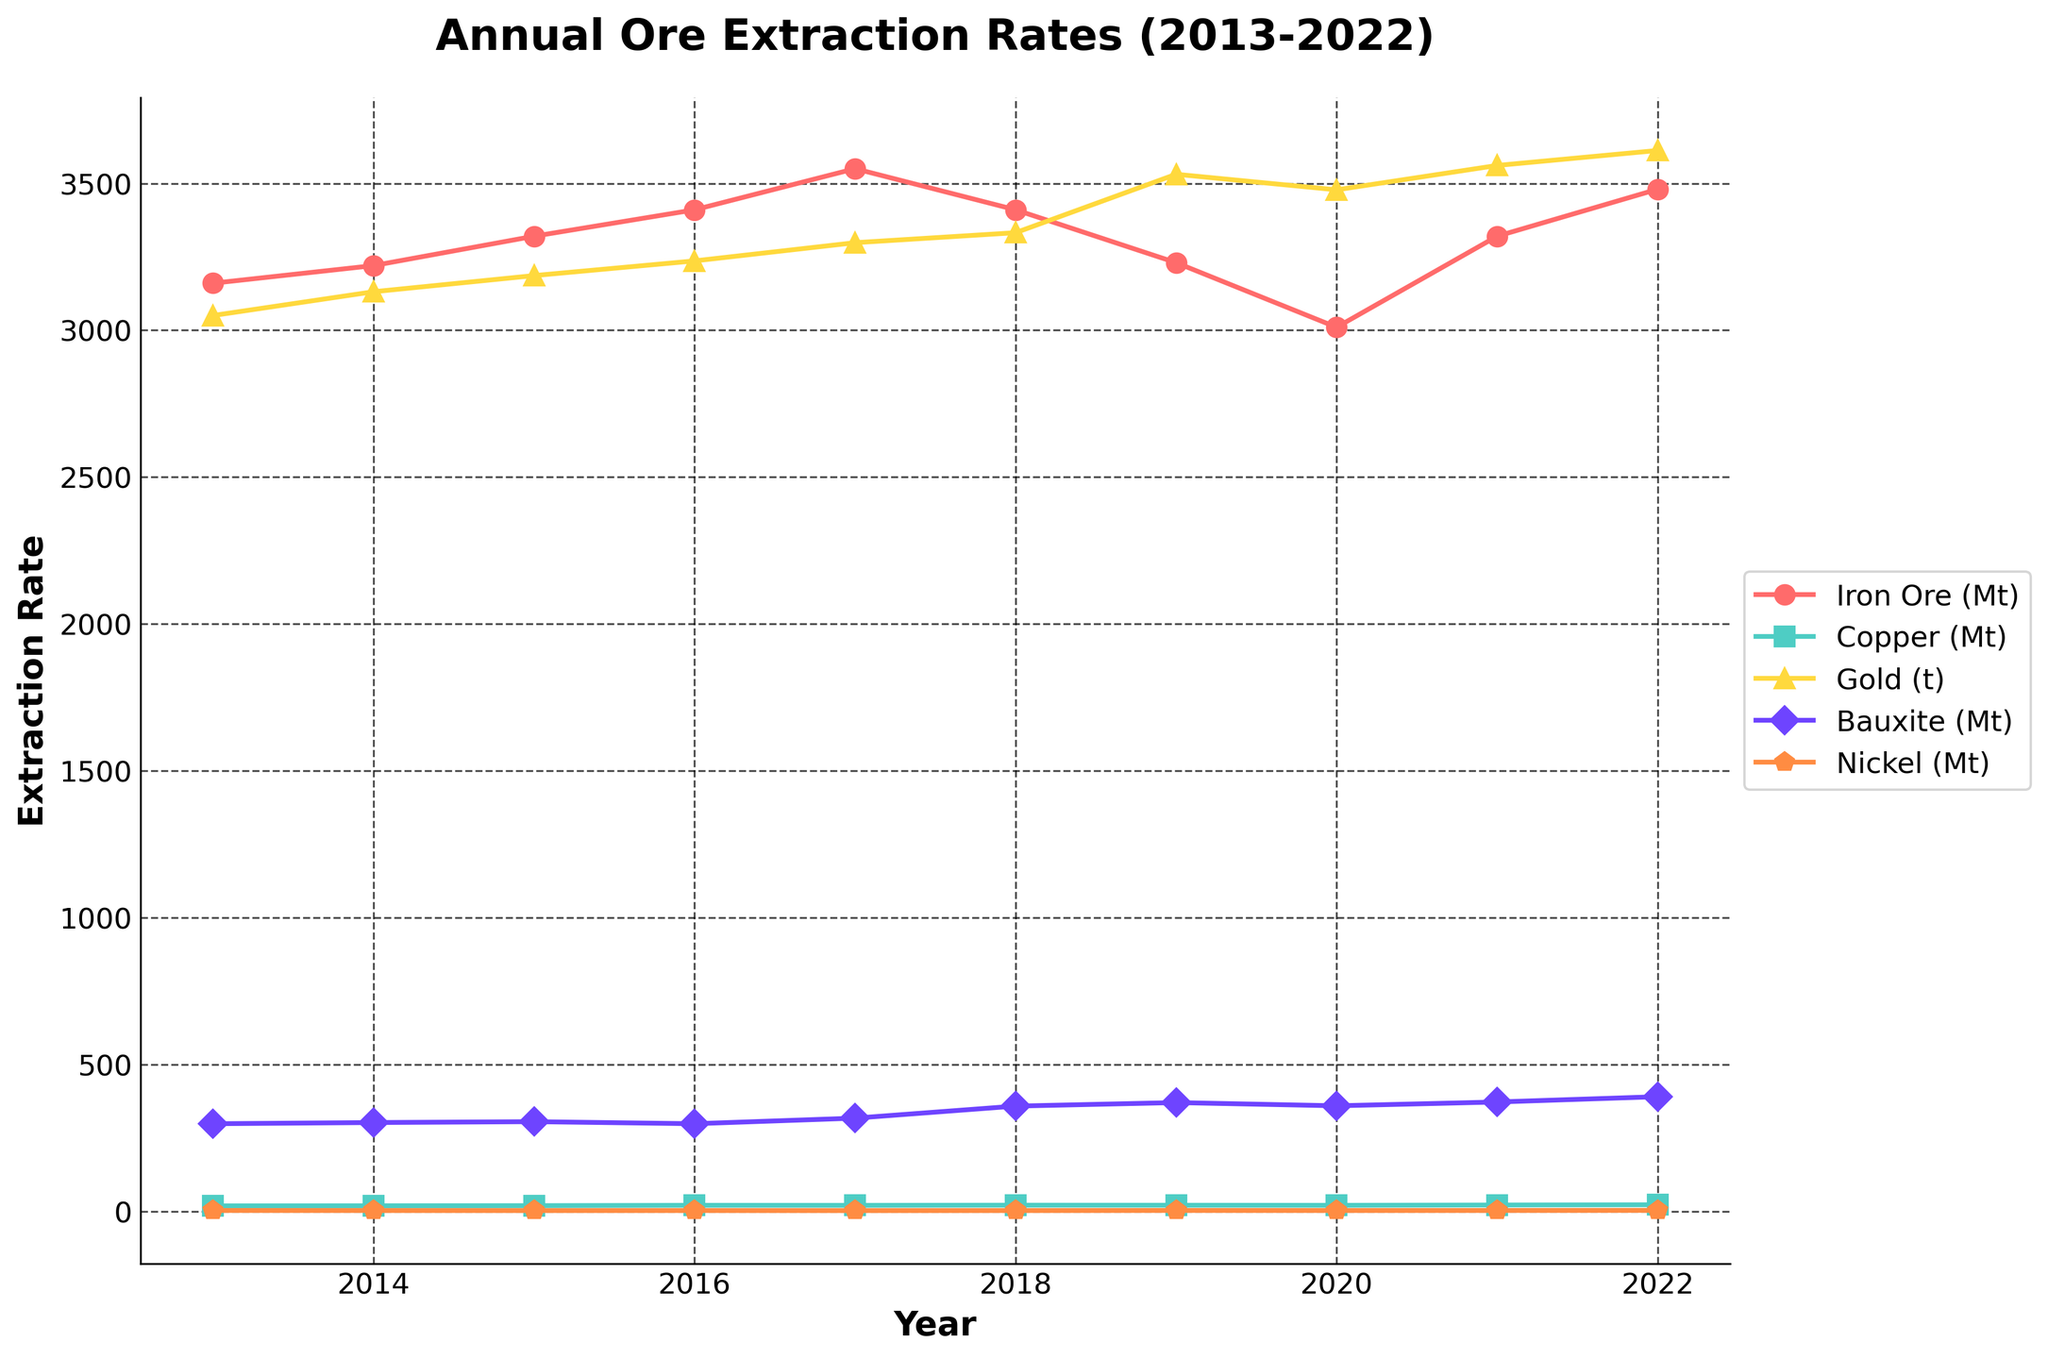Which mineral had the highest extraction rate in 2021? Look at the data points for 2021 and compare the extraction rates of all minerals. Iron Ore had the highest value.
Answer: Iron Ore Which mineral showed the most significant increase in extraction rate from 2013 to 2022? Check the values for each mineral in 2013 and 2022 and calculate the difference. Gold increased from 3050 to 3612, the most significant rise.
Answer: Gold Did any minerals experience a decrease in extraction rate from 2019 to 2020? If so, which ones? Compare the values for each mineral between 2019 and 2020. Iron Ore decreased from 3230 to 3010.
Answer: Iron Ore Which year had the highest extraction rate for Bauxite? Examine the extraction rates for Bauxite across all years and identify the maximum value, which occurred in 2022.
Answer: 2022 How does the extraction rate of Nickel in 2022 compare to 2013? Compare the extraction rate of Nickel in 2013 and 2022. It increased from 2.63 to 2.93.
Answer: Increased What was the total extraction rate of Copper over the past decade? Sum the extraction rates of Copper from 2013 to 2022: 18.3 + 18.7 + 19.1 + 20.2 + 20.0 + 20.6 + 20.4 + 20.1 + 21.2 + 22.0 = 200.6.
Answer: 200.6 Mt In which year did Iron Ore have its lowest extraction rate, and what was the value? Find the minimum value for Iron Ore across all years and note the corresponding year. It was lowest in 2020 with 3010 Mt.
Answer: 2020, 3010 Mt Compare the extraction rates of Copper and Nickel in 2015. Which was higher? Look at the extraction rates for Copper and Nickel in 2015. Copper had 19.1 Mt, while Nickel had 2.28 Mt, so Copper was higher.
Answer: Copper 